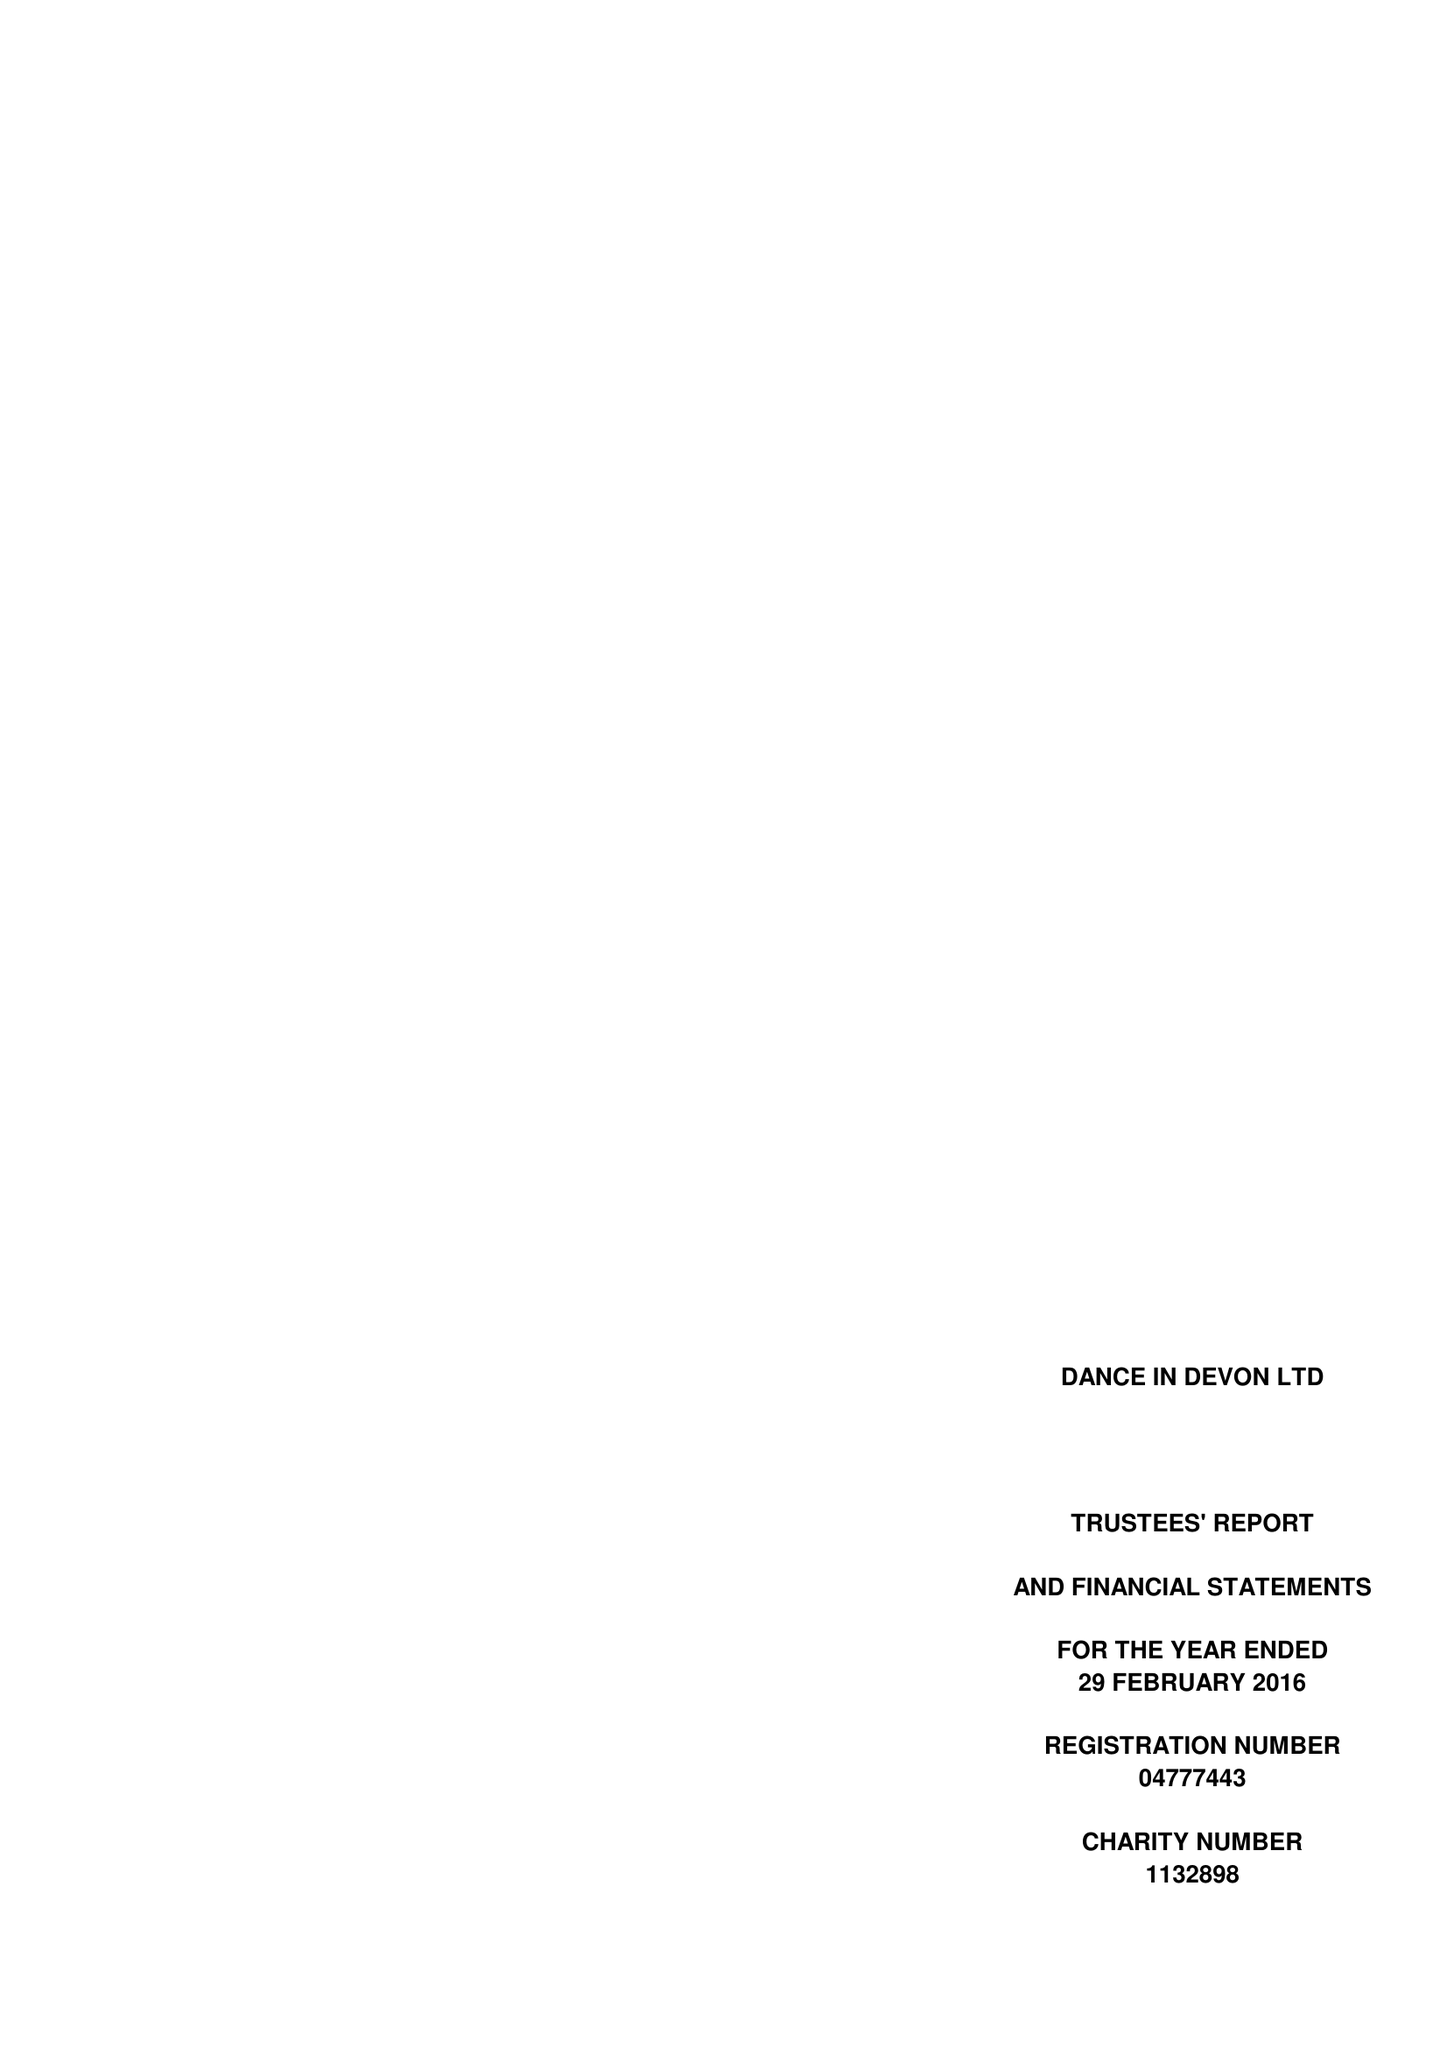What is the value for the charity_number?
Answer the question using a single word or phrase. 1132898 